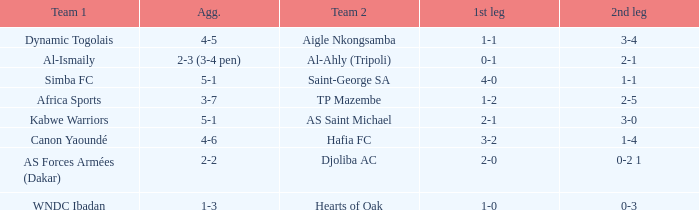When kabwe warriors (team 1) participated, what was the conclusion of the 1st leg? 2-1. 